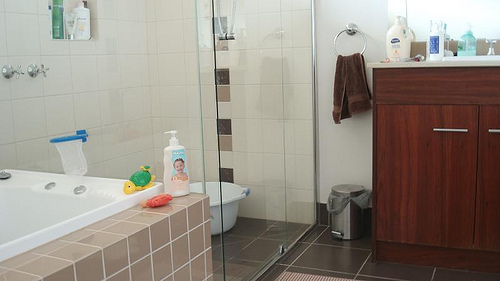Please provide the bounding box coordinate of the region this sentence describes: A white bucket on the floor. The coordinates for the region with a white bucket on the floor are [0.37, 0.57, 0.5, 0.69]. 